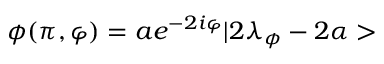Convert formula to latex. <formula><loc_0><loc_0><loc_500><loc_500>\phi ( \pi , \varphi ) = a e ^ { - 2 i \varphi } | 2 \lambda _ { \phi } - 2 \alpha ></formula> 